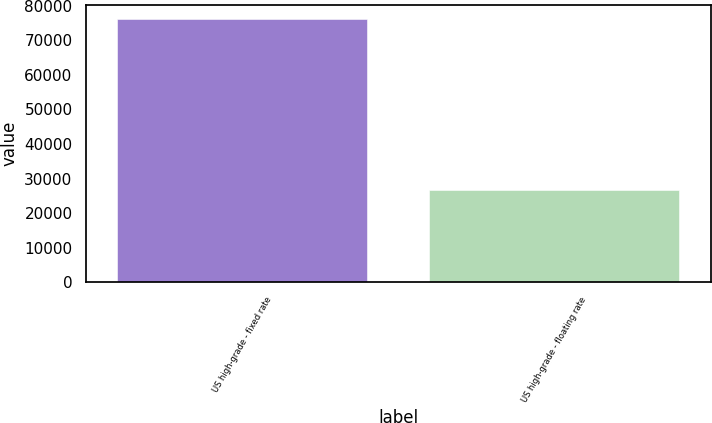Convert chart to OTSL. <chart><loc_0><loc_0><loc_500><loc_500><bar_chart><fcel>US high-grade - fixed rate<fcel>US high-grade - floating rate<nl><fcel>76324<fcel>26815<nl></chart> 